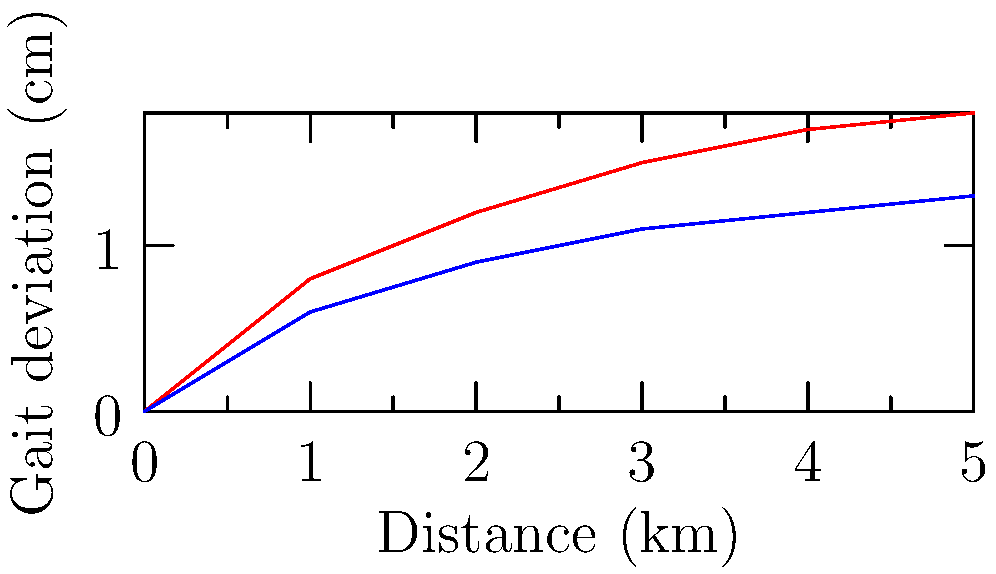The graph shows gait deviation measurements for pilgrims walking long distances compared to a control group. What principle of biomechanics might explain the increased gait deviation in pilgrims, and how could this information be used to support their spiritual journey while preserving their physical well-being? To answer this question, we need to consider several biomechanical principles and their application to the given scenario:

1. Fatigue and gait deviation:
   - The graph shows that pilgrims have a higher gait deviation compared to the control group.
   - This increased deviation is likely due to muscular fatigue from prolonged walking.

2. Biomechanical principle - Energy conservation:
   - The body aims to minimize energy expenditure during locomotion.
   - As fatigue sets in, the body may compensate by altering gait patterns, leading to increased deviation.

3. Impact on joints and tissues:
   - Increased gait deviation can lead to abnormal stress on joints and soft tissues.
   - This may result in discomfort or potential injury over long distances.

4. Application to spiritual journey:
   - Understanding these biomechanical principles can help in designing appropriate rest periods and walking strategies for pilgrims.
   - This knowledge can be used to balance the spiritual aspect of the pilgrimage with the physical well-being of the participants.

5. Preservation of physical well-being:
   - Implementing regular rest stops and stretching exercises can help mitigate fatigue.
   - Providing proper footwear and walking aids can support correct gait patterns.
   - Educating pilgrims about proper walking techniques can help maintain a more efficient gait.

6. Spiritual consideration:
   - From a Christian perspective, caring for one's physical body (as a temple of the Holy Spirit) aligns with spiritual devotion.
   - Balancing physical care with spiritual goals can enhance the overall pilgrimage experience.

The principle of energy conservation in biomechanics explains the increased gait deviation, and this information can be used to design strategies that support both the spiritual and physical aspects of the pilgrimage.
Answer: Energy conservation principle; implement rest periods, proper footwear, and education on walking techniques. 